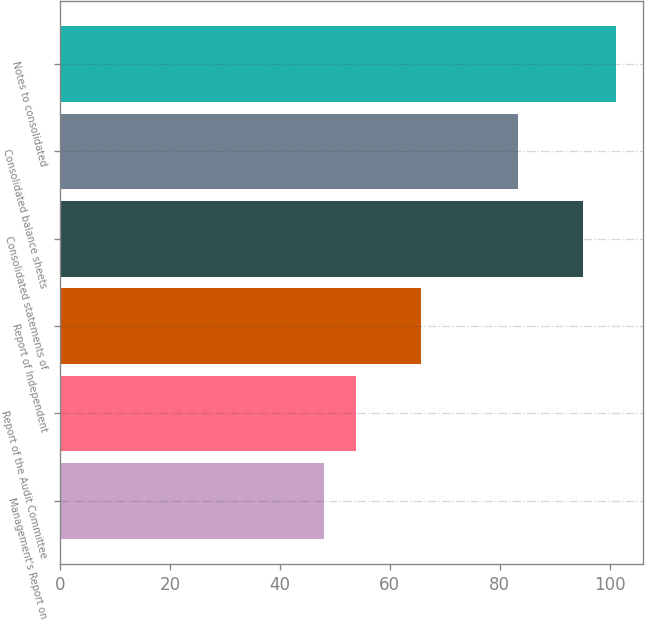Convert chart to OTSL. <chart><loc_0><loc_0><loc_500><loc_500><bar_chart><fcel>Management's Report on<fcel>Report of the Audit Committee<fcel>Report of Independent<fcel>Consolidated statements of<fcel>Consolidated balance sheets<fcel>Notes to consolidated<nl><fcel>48<fcel>53.9<fcel>65.7<fcel>95.2<fcel>83.4<fcel>101.1<nl></chart> 